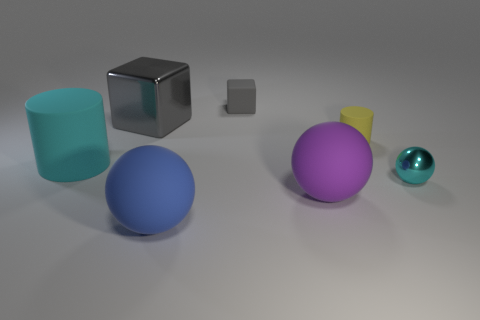There is a cube that is the same material as the yellow thing; what is its color?
Your answer should be very brief. Gray. Are there any purple spheres that have the same size as the blue ball?
Ensure brevity in your answer.  Yes. How many objects are either small matte objects on the left side of the purple matte ball or gray things that are to the left of the blue thing?
Your answer should be compact. 2. There is a gray thing that is the same size as the purple rubber ball; what shape is it?
Make the answer very short. Cube. Is there another small object of the same shape as the purple matte thing?
Ensure brevity in your answer.  Yes. Is the number of small cylinders less than the number of small yellow shiny spheres?
Your response must be concise. No. Does the cube in front of the tiny block have the same size as the rubber cylinder that is to the left of the small yellow thing?
Ensure brevity in your answer.  Yes. How many objects are gray metallic cubes or big cyan spheres?
Give a very brief answer. 1. What size is the cyan object that is left of the rubber block?
Your response must be concise. Large. There is a gray block left of the tiny rubber object to the left of the large purple ball; what number of matte things are in front of it?
Your answer should be very brief. 4. 